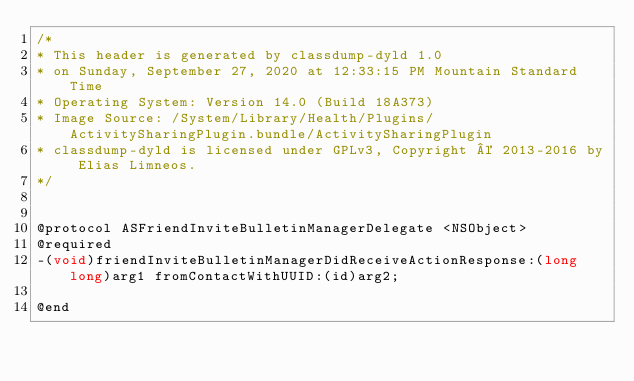<code> <loc_0><loc_0><loc_500><loc_500><_C_>/*
* This header is generated by classdump-dyld 1.0
* on Sunday, September 27, 2020 at 12:33:15 PM Mountain Standard Time
* Operating System: Version 14.0 (Build 18A373)
* Image Source: /System/Library/Health/Plugins/ActivitySharingPlugin.bundle/ActivitySharingPlugin
* classdump-dyld is licensed under GPLv3, Copyright © 2013-2016 by Elias Limneos.
*/


@protocol ASFriendInviteBulletinManagerDelegate <NSObject>
@required
-(void)friendInviteBulletinManagerDidReceiveActionResponse:(long long)arg1 fromContactWithUUID:(id)arg2;

@end

</code> 